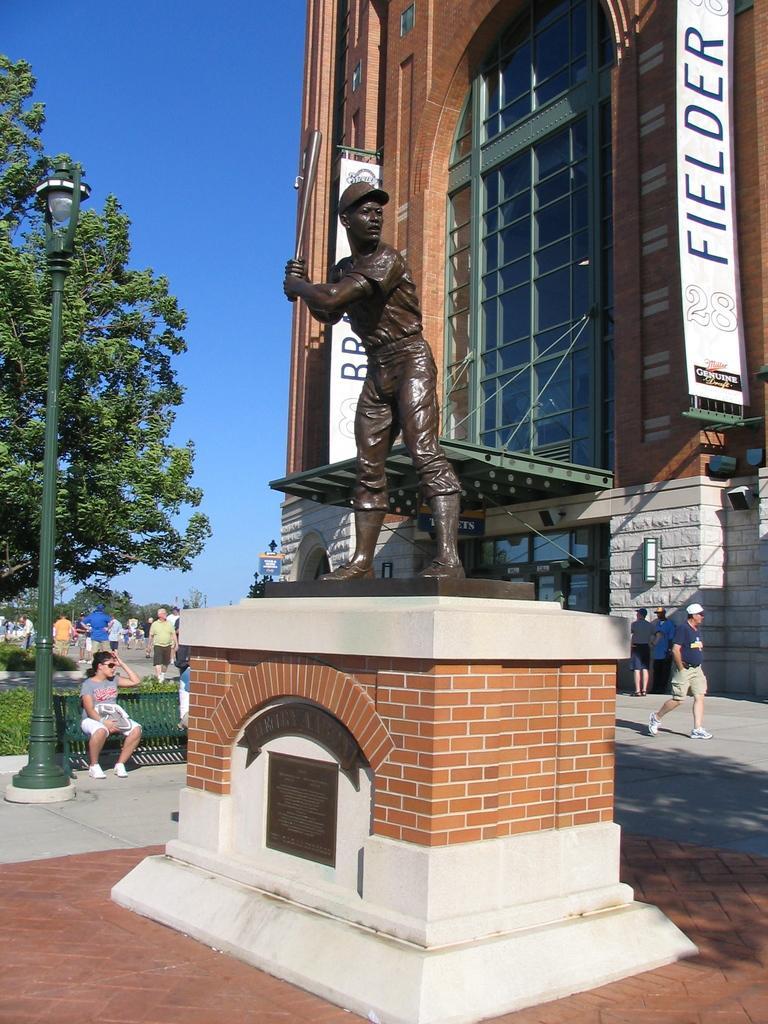In one or two sentences, can you explain what this image depicts? In this image I can see a brown colour sculpture of a man in the front. In the background I can see few people, a bench, a light, a pole, a building, few trees, the sky and shadows. On the right side I can see two boards and on these words I can see something is written. 